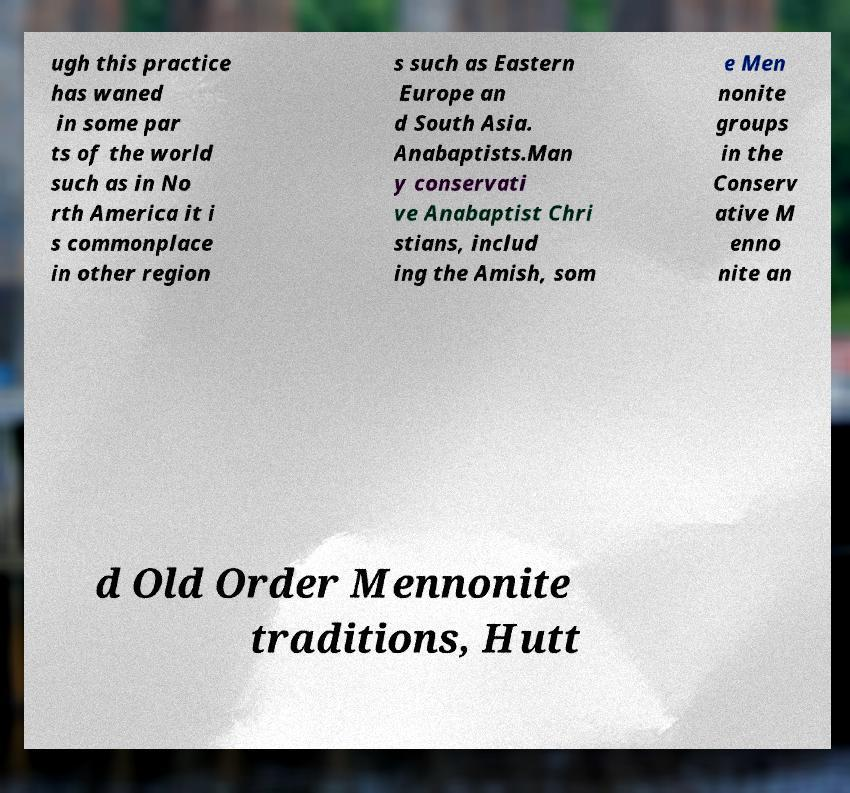For documentation purposes, I need the text within this image transcribed. Could you provide that? ugh this practice has waned in some par ts of the world such as in No rth America it i s commonplace in other region s such as Eastern Europe an d South Asia. Anabaptists.Man y conservati ve Anabaptist Chri stians, includ ing the Amish, som e Men nonite groups in the Conserv ative M enno nite an d Old Order Mennonite traditions, Hutt 